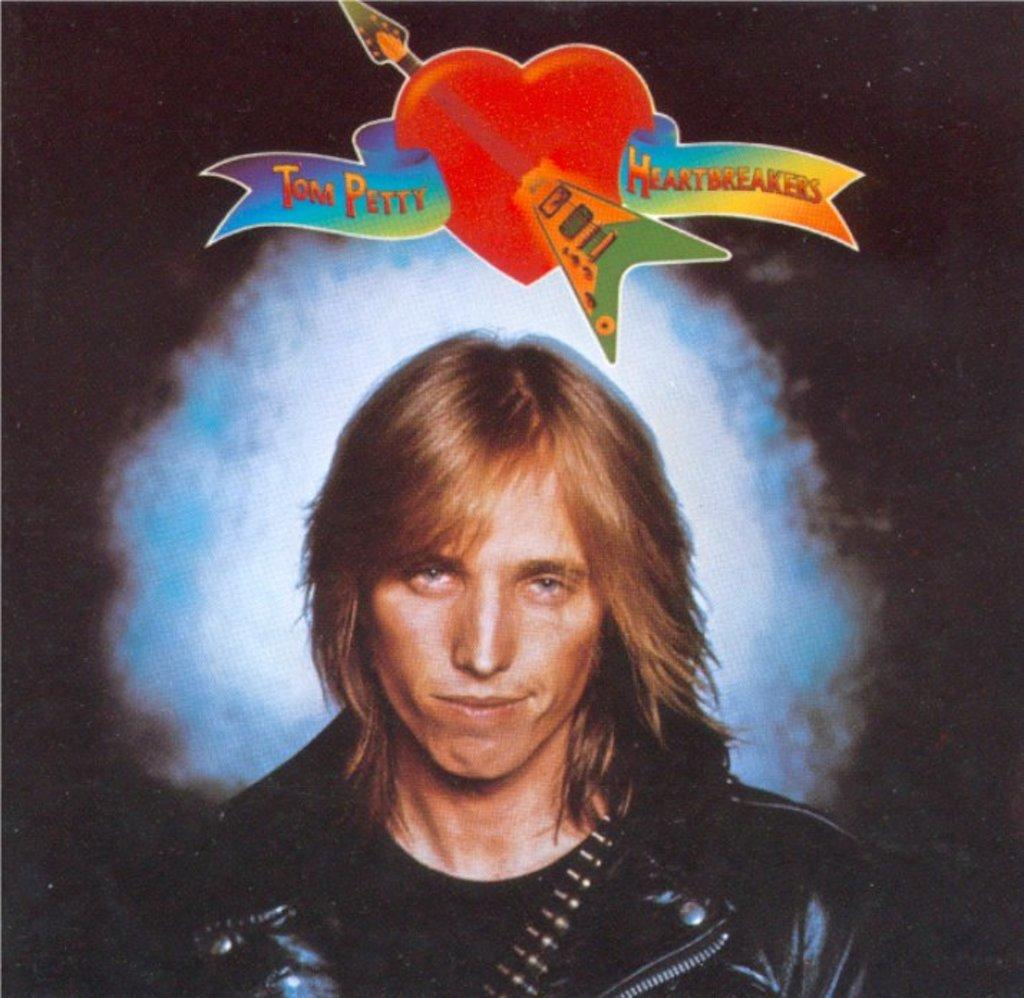Who is present in the image? There is a man in the image. What is the man wearing? The man is wearing a black jacket. What symbols can be seen on top of the image? There is a heart and an arrow on top of the image. What type of light is visible in the image? There is a blue light in the image. What color is the background of the image? The background of the image is black. What type of tail is visible on the man in the image? There is no tail visible on the man in the image. What type of suit is the man wearing in the image? The provided facts do not mention a suit; the man is wearing a black jacket. 